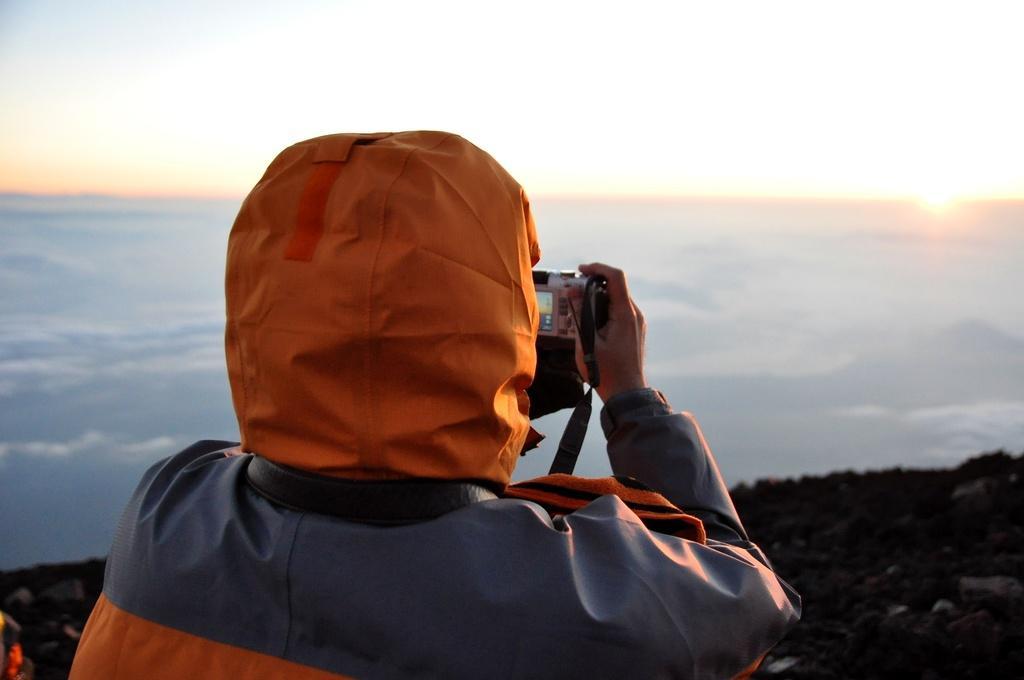In one or two sentences, can you explain what this image depicts? In the bottom left corner of the image a person is standing and holding a camera. In front of him we can see some hills, clouds and sun in the sky. 